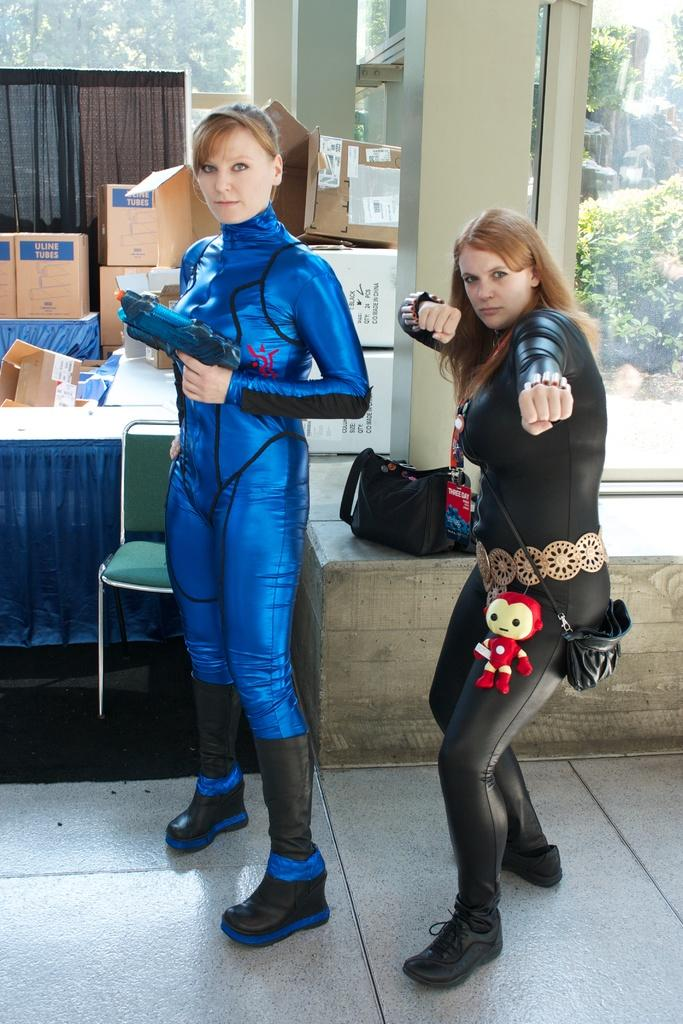What is happening in the center of the image? There are women standing in the center of the image. What is the surface the women are standing on? The women are standing on the floor. What can be seen in the background of the image? There are boxes, pillars, windows, plants, and trees in the background of the image. What type of ornament is hanging from the ceiling in the image? There is no ornament hanging from the ceiling in the image. What rule is being enforced by the women in the image? There is no indication of any rule being enforced by the women in the image. 